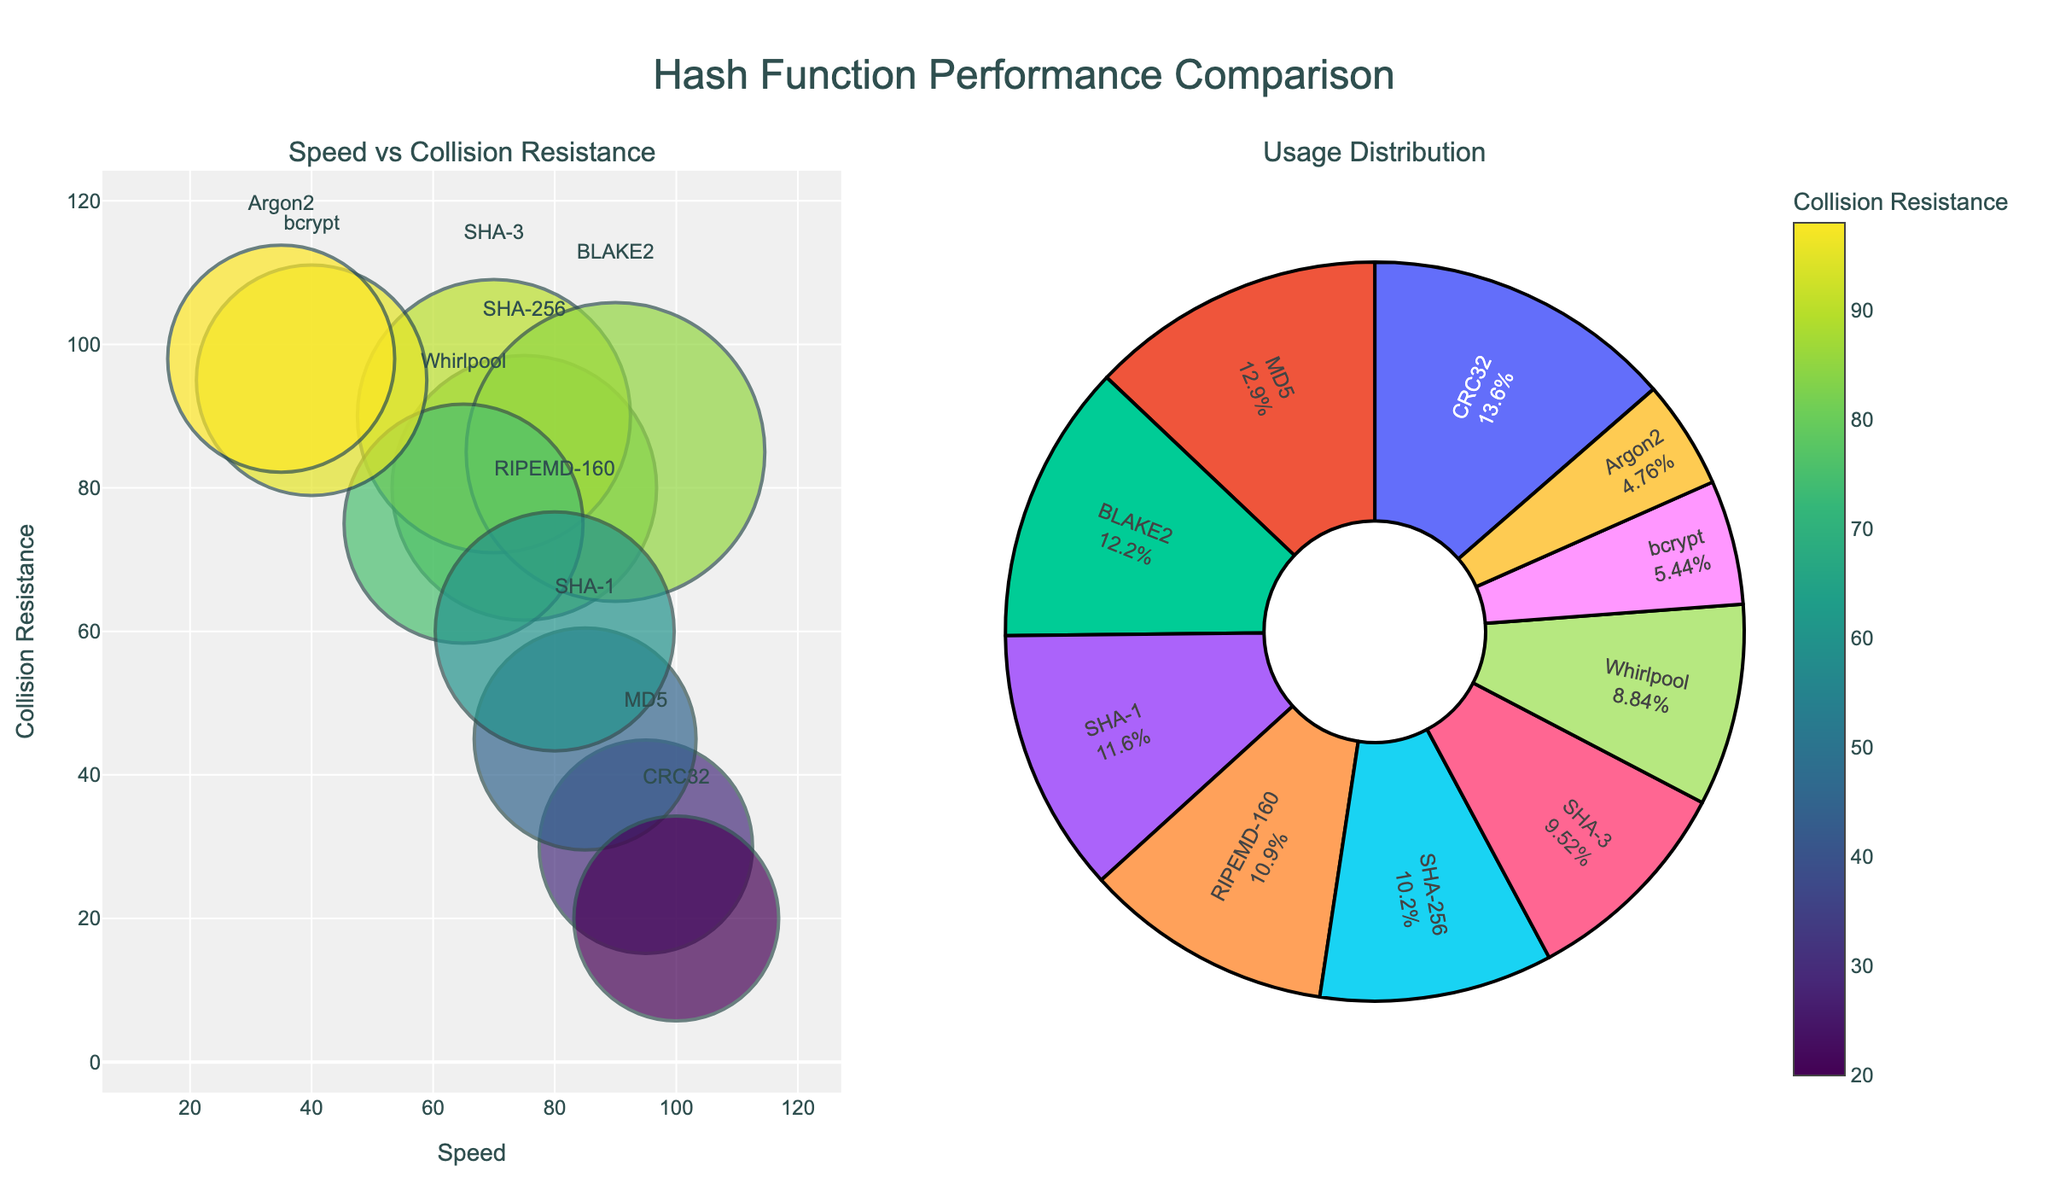What’s the title of the figure? The title of the figure is located at the top center and is typically in a larger font size to draw attention. Its text reads, "Correlation between Bushfire Occurrences and Annual Temperatures in Australian States."
Answer: Correlation between Bushfire Occurrences and Annual Temperatures in Australian States How many data points are there for each state? Count the number of markers in each subplot. Each marker represents a data point. For New South Wales, Victoria, Queensland, and Western Australia, there are 5 markers each.
Answer: 5 Which state has the highest temperature recorded, and what is it? Look at the scales on the x-axes on each subplot. Queensland in the top right corner has the highest temperature recorded, marked in 2019, with a value of 28.2°C.
Answer: Queensland, 28.2°C How many bushfire occurrences were recorded in Victoria in 2018? Locate the Victoria subplot in the bottom left corner and find the marker labeled with the year 2018. The y-axis value indicates there were 67 bushfire occurrences.
Answer: 67 Which state shows the steepest increase in bushfire occurrences with increasing temperature? Compare the slopes of the trends in each subplot. New South Wales (top left) shows the steepest increase, with a noticeable rise from 78 occurrences at 23.1°C to 115 occurrences at 25.3°C.
Answer: New South Wales Which year had the lowest annual temperature in Western Australia? Locate the Western Australia subplot in the bottom right corner. The marker with the lowest x-axis value (25.7°C) represents the year 2015.
Answer: 2015 On average, how many bushfire occurrences were there in New South Wales across the years shown? Add the occurrences for all the years in New South Wales (78, 85, 92, 103, 115) and divide by the number of years (5). The calculation is (78 + 85 + 92 + 103 + 115) / 5 = 94.6.
Answer: 94.6 Comparing 2015 data, which state had the most bushfire occurrences? Locate the markers for 2015 in each subplot. Victoria had 45, Queensland had 62, New South Wales had 78, and Western Australia had 55. New South Wales had the most with 78 occurrences.
Answer: New South Wales Does the bushfire occurrence tend to increase or decrease with rising temperatures in Queensland? Observe the trend in the subplot for Queensland in the top right corner. The number of bushfire occurrences increases from 62 at 26.4°C in 2015 to 91 at 28.2°C in 2019.
Answer: Increase What is the correlation trend between annual temperature and bushfire occurrences in Victoria? Analyze the Victoria subplot in the bottom left corner. There is an upward trend, indicating a positive correlation as bushfire occurrences increase with rising annual temperatures.
Answer: Positive correlation 